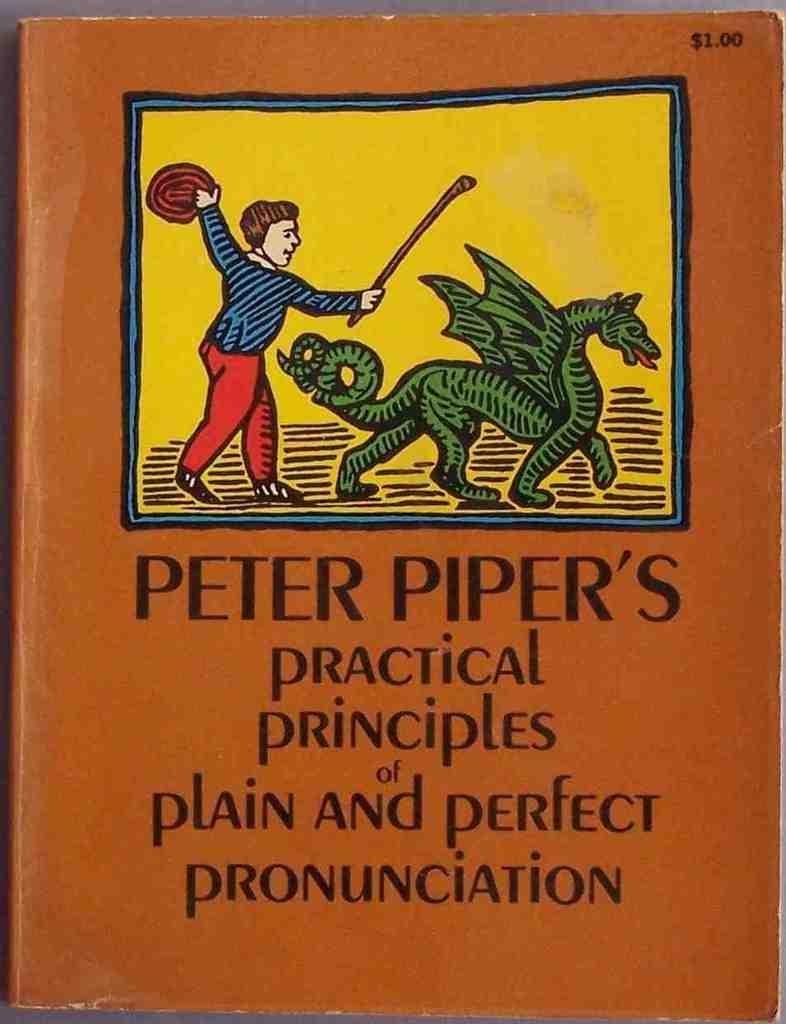Please provide a concise description of this image. In this picture I can see a cover page of a book and I can see a cartoon picture and text at the bottom of the picture. 